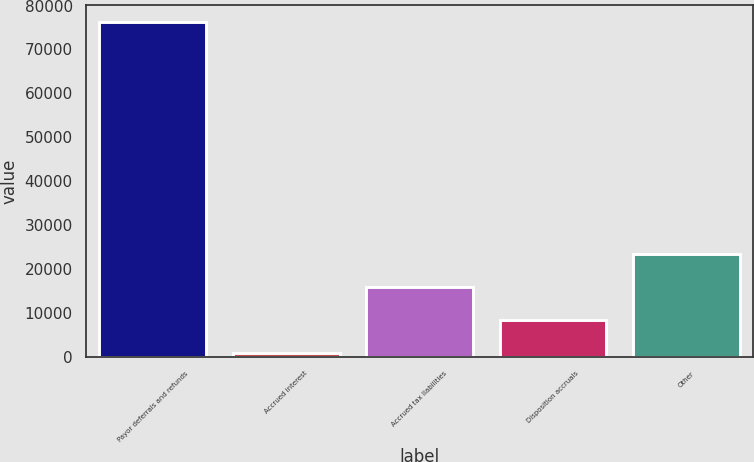Convert chart to OTSL. <chart><loc_0><loc_0><loc_500><loc_500><bar_chart><fcel>Payor deferrals and refunds<fcel>Accrued interest<fcel>Accrued tax liabilities<fcel>Disposition accruals<fcel>Other<nl><fcel>76235<fcel>878<fcel>15949.4<fcel>8413.7<fcel>23485.1<nl></chart> 